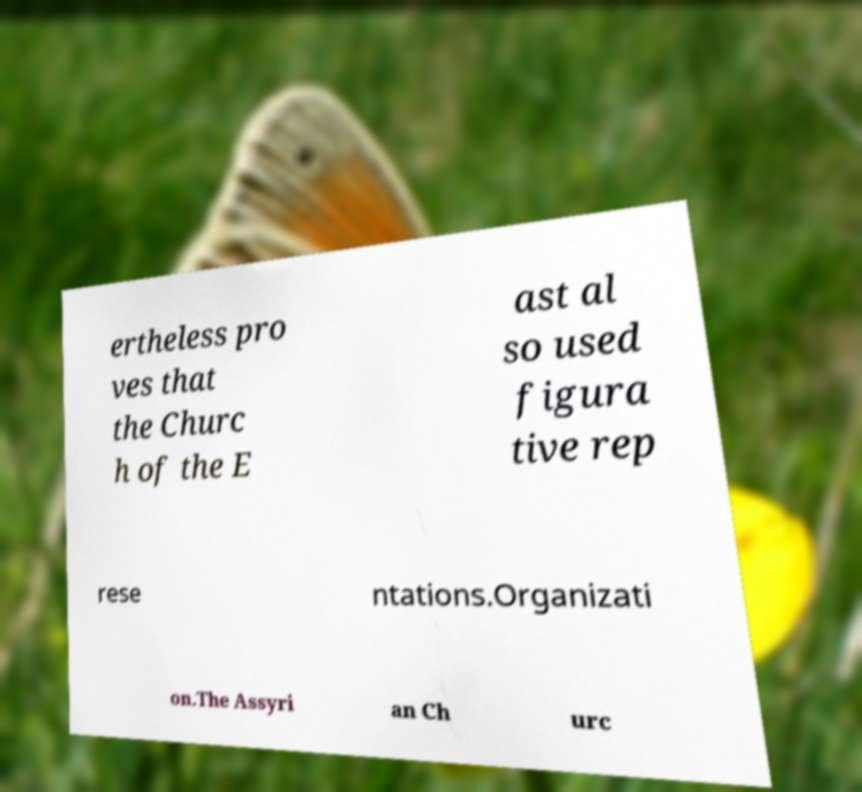Can you read and provide the text displayed in the image?This photo seems to have some interesting text. Can you extract and type it out for me? ertheless pro ves that the Churc h of the E ast al so used figura tive rep rese ntations.Organizati on.The Assyri an Ch urc 